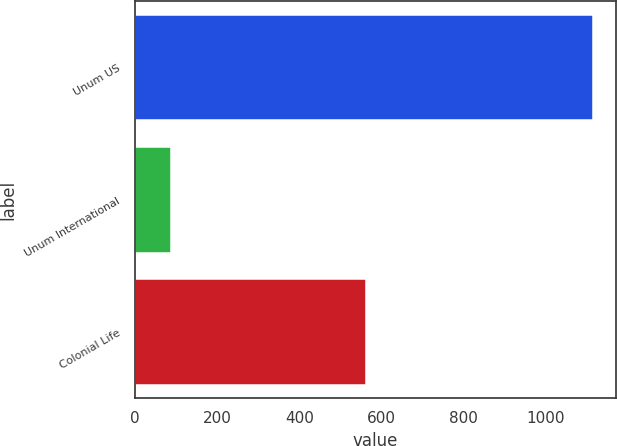Convert chart. <chart><loc_0><loc_0><loc_500><loc_500><bar_chart><fcel>Unum US<fcel>Unum International<fcel>Colonial Life<nl><fcel>1114.6<fcel>87<fcel>561.3<nl></chart> 